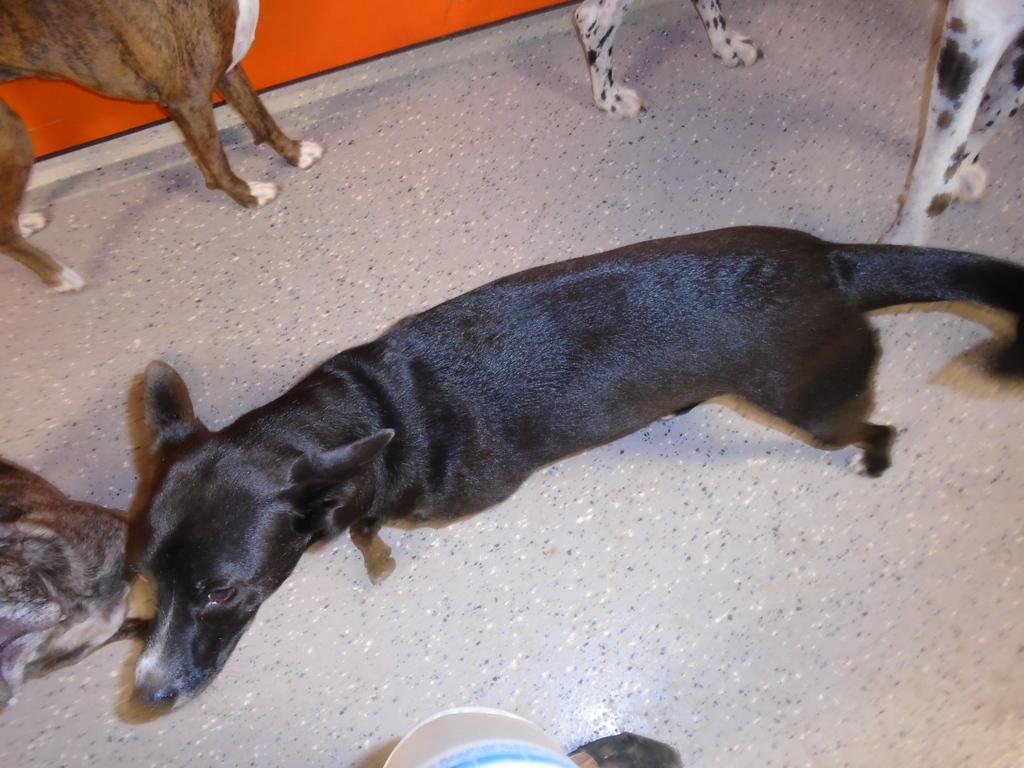What type of animals are present in the image? There are dogs in the image. Can you describe the color of one of the dogs? One of the dogs is black in color. What color is the background wall in the image? The background wall is orange in color. How many kittens are playing with the black dog in the image? There are no kittens present in the image; it features dogs only. What type of bird can be seen flying in the background of the image? There is no bird visible in the image; it only shows dogs and an orange wall in the background. 